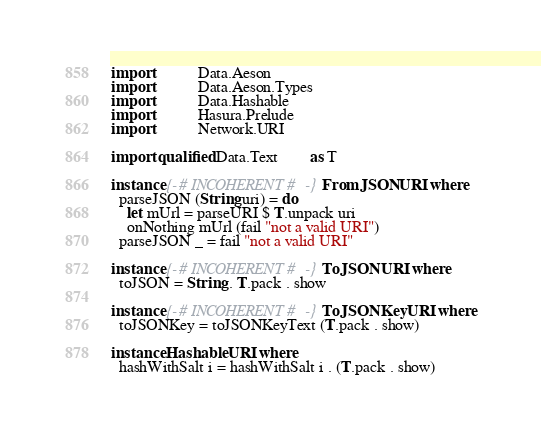Convert code to text. <code><loc_0><loc_0><loc_500><loc_500><_Haskell_>
import           Data.Aeson
import           Data.Aeson.Types
import           Data.Hashable
import           Hasura.Prelude
import           Network.URI

import qualified Data.Text        as T

instance {-# INCOHERENT #-} FromJSON URI where
  parseJSON (String uri) = do
    let mUrl = parseURI $ T.unpack uri
    onNothing mUrl (fail "not a valid URI")
  parseJSON _ = fail "not a valid URI"

instance {-# INCOHERENT #-} ToJSON URI where
  toJSON = String . T.pack . show

instance {-# INCOHERENT #-} ToJSONKey URI where
  toJSONKey = toJSONKeyText (T.pack . show)

instance Hashable URI where
  hashWithSalt i = hashWithSalt i . (T.pack . show)
</code> 